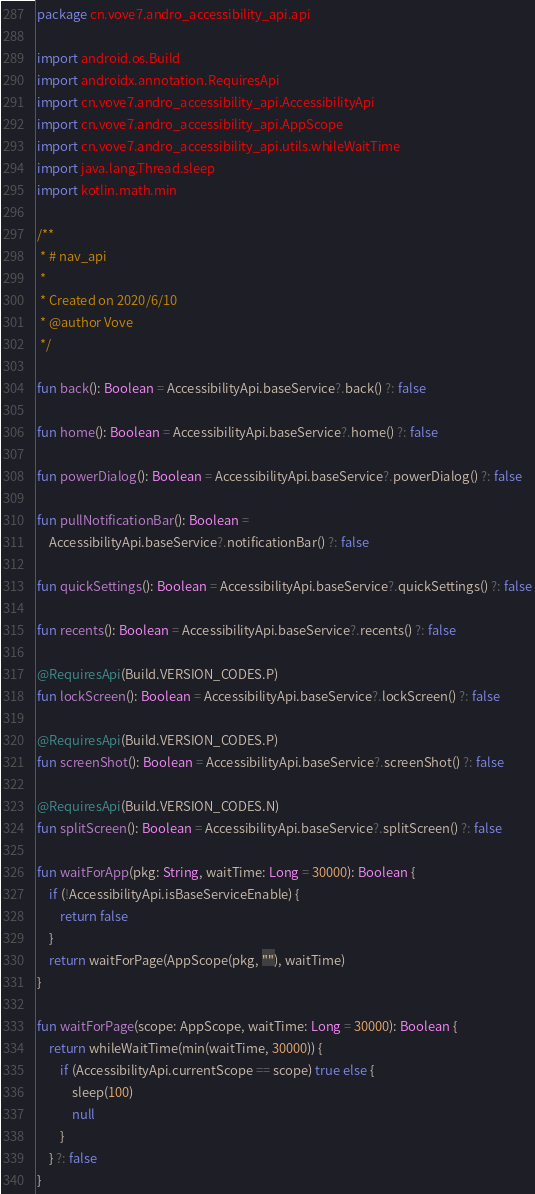<code> <loc_0><loc_0><loc_500><loc_500><_Kotlin_>package cn.vove7.andro_accessibility_api.api

import android.os.Build
import androidx.annotation.RequiresApi
import cn.vove7.andro_accessibility_api.AccessibilityApi
import cn.vove7.andro_accessibility_api.AppScope
import cn.vove7.andro_accessibility_api.utils.whileWaitTime
import java.lang.Thread.sleep
import kotlin.math.min

/**
 * # nav_api
 *
 * Created on 2020/6/10
 * @author Vove
 */

fun back(): Boolean = AccessibilityApi.baseService?.back() ?: false

fun home(): Boolean = AccessibilityApi.baseService?.home() ?: false

fun powerDialog(): Boolean = AccessibilityApi.baseService?.powerDialog() ?: false

fun pullNotificationBar(): Boolean =
    AccessibilityApi.baseService?.notificationBar() ?: false

fun quickSettings(): Boolean = AccessibilityApi.baseService?.quickSettings() ?: false

fun recents(): Boolean = AccessibilityApi.baseService?.recents() ?: false

@RequiresApi(Build.VERSION_CODES.P)
fun lockScreen(): Boolean = AccessibilityApi.baseService?.lockScreen() ?: false

@RequiresApi(Build.VERSION_CODES.P)
fun screenShot(): Boolean = AccessibilityApi.baseService?.screenShot() ?: false

@RequiresApi(Build.VERSION_CODES.N)
fun splitScreen(): Boolean = AccessibilityApi.baseService?.splitScreen() ?: false

fun waitForApp(pkg: String, waitTime: Long = 30000): Boolean {
    if (!AccessibilityApi.isBaseServiceEnable) {
        return false
    }
    return waitForPage(AppScope(pkg, ""), waitTime)
}

fun waitForPage(scope: AppScope, waitTime: Long = 30000): Boolean {
    return whileWaitTime(min(waitTime, 30000)) {
        if (AccessibilityApi.currentScope == scope) true else {
            sleep(100)
            null
        }
    } ?: false
}</code> 